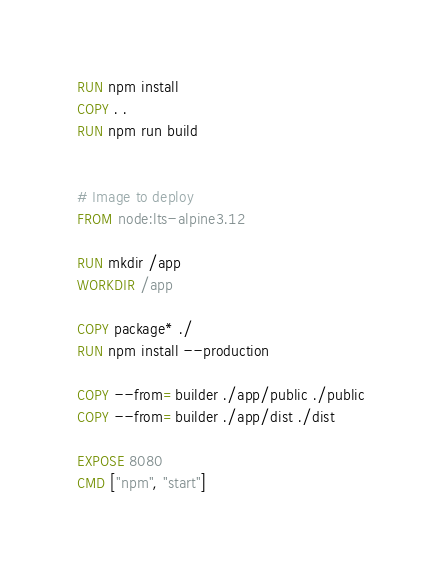Convert code to text. <code><loc_0><loc_0><loc_500><loc_500><_Dockerfile_>RUN npm install
COPY . .
RUN npm run build


# Image to deploy
FROM node:lts-alpine3.12

RUN mkdir /app
WORKDIR /app

COPY package* ./
RUN npm install --production

COPY --from=builder ./app/public ./public
COPY --from=builder ./app/dist ./dist

EXPOSE 8080
CMD ["npm", "start"]
</code> 